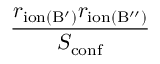<formula> <loc_0><loc_0><loc_500><loc_500>\frac { r _ { i o n ( B ^ { \prime } ) } r _ { i o n ( B ^ { \prime \prime } ) } } { S _ { c o n f } }</formula> 